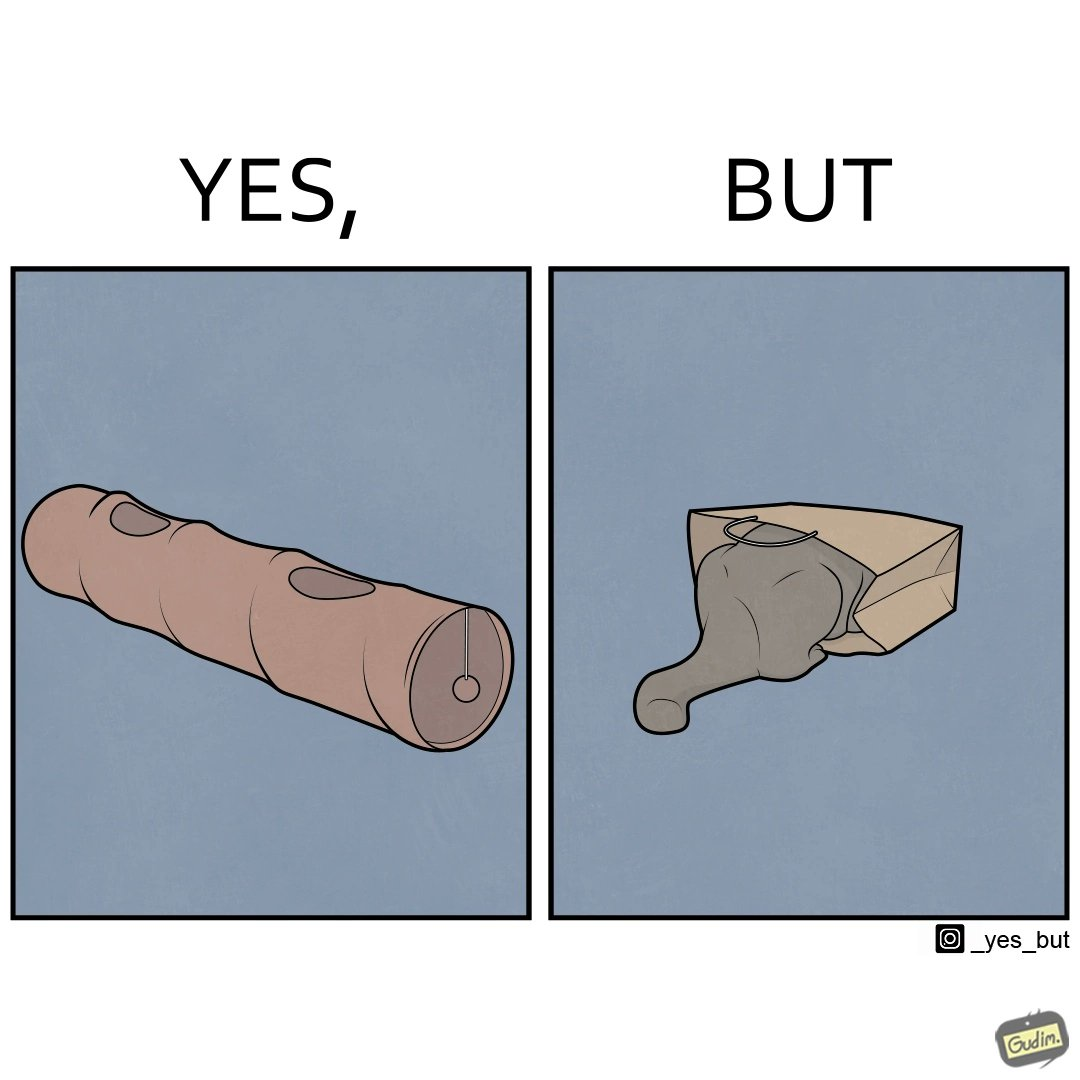What is shown in the left half versus the right half of this image? In the left part of the image: a long piece of cylinder with two circular holes over its surface and two holes at top and bottom and a hanging toy at one end In the right part of the image: an animal hiding its face in a paper bag, probably a cat or dog 